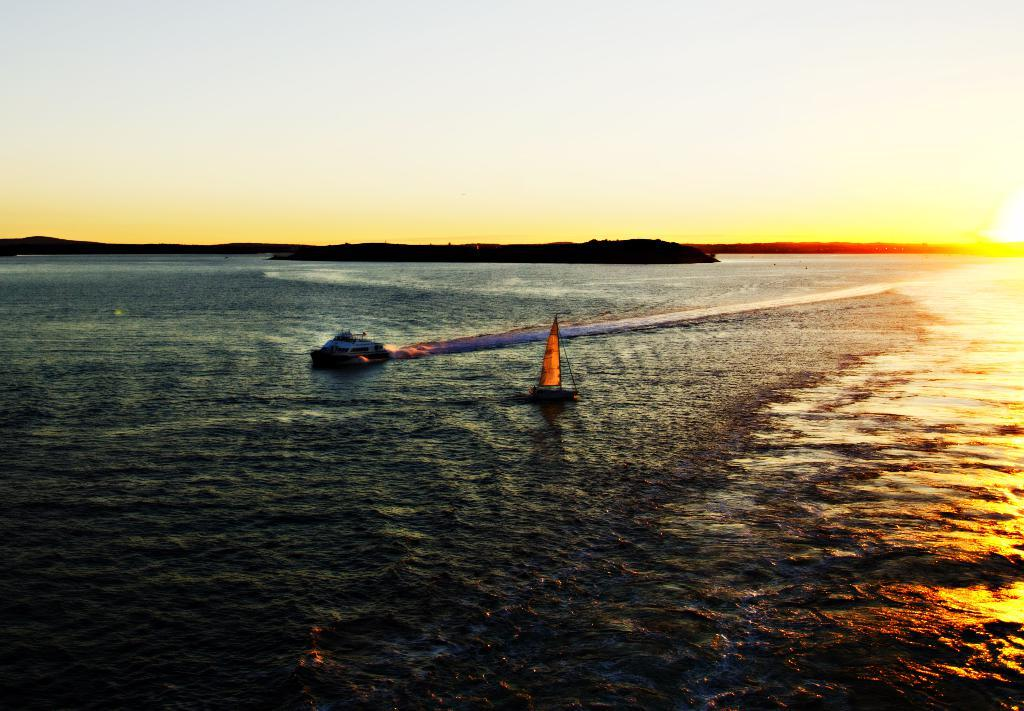What is the setting of the image? The image has an outside view. What can be seen in the foreground of the image? There are boats floating on the sea in the foreground. What is visible in the background of the image? The sky is visible in the background. How many rings are hanging from the lift in the image? There is no lift or rings present in the image; it features boats floating on the sea and a visible sky. 